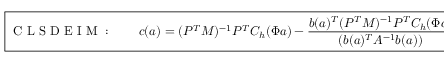Convert formula to latex. <formula><loc_0><loc_0><loc_500><loc_500>\boxed { C L S D E I M \colon \quad c ( a ) = ( P ^ { T } M ) ^ { - 1 } P ^ { T } C _ { h } ( \Phi a ) - \frac { b ( a ) ^ { T } ( P ^ { T } M ) ^ { - 1 } P ^ { T } C _ { h } ( \Phi a ) } { ( b ( a ) ^ { T } A ^ { - 1 } b ( a ) ) } A ^ { - 1 } b ( a ) . }</formula> 